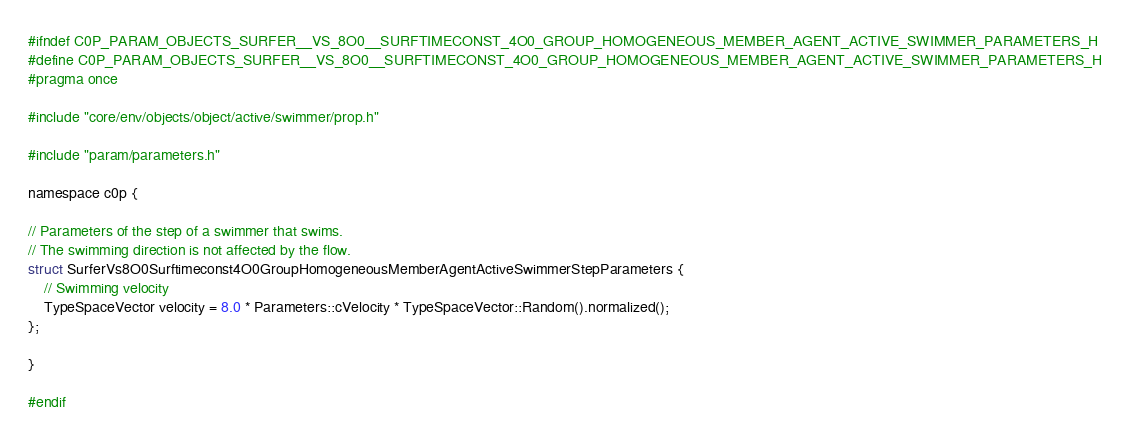<code> <loc_0><loc_0><loc_500><loc_500><_C_>#ifndef C0P_PARAM_OBJECTS_SURFER__VS_8O0__SURFTIMECONST_4O0_GROUP_HOMOGENEOUS_MEMBER_AGENT_ACTIVE_SWIMMER_PARAMETERS_H
#define C0P_PARAM_OBJECTS_SURFER__VS_8O0__SURFTIMECONST_4O0_GROUP_HOMOGENEOUS_MEMBER_AGENT_ACTIVE_SWIMMER_PARAMETERS_H
#pragma once

#include "core/env/objects/object/active/swimmer/prop.h"

#include "param/parameters.h"

namespace c0p {

// Parameters of the step of a swimmer that swims.
// The swimming direction is not affected by the flow.
struct SurferVs8O0Surftimeconst4O0GroupHomogeneousMemberAgentActiveSwimmerStepParameters {
    // Swimming velocity
    TypeSpaceVector velocity = 8.0 * Parameters::cVelocity * TypeSpaceVector::Random().normalized();
};

}

#endif
</code> 